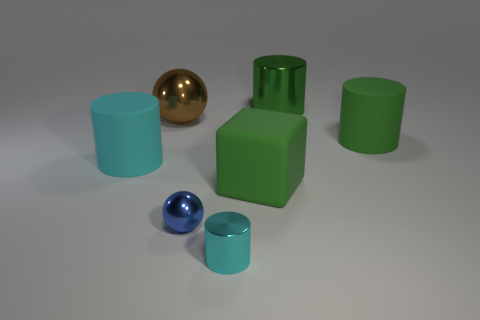Do the large green thing behind the large brown metallic thing and the big green block have the same material?
Your answer should be very brief. No. The large sphere that is made of the same material as the tiny cyan thing is what color?
Your response must be concise. Brown. Is the number of matte cubes that are behind the brown thing less than the number of rubber cylinders that are to the right of the green metallic thing?
Make the answer very short. Yes. There is a thing that is behind the brown sphere; is it the same color as the matte thing that is in front of the cyan matte cylinder?
Offer a terse response. Yes. Is there a big brown sphere that has the same material as the tiny cyan object?
Offer a terse response. Yes. What is the size of the cyan object right of the ball that is on the left side of the tiny blue sphere?
Make the answer very short. Small. Are there more small green metal spheres than small shiny cylinders?
Provide a short and direct response. No. There is a green rubber thing in front of the green rubber cylinder; is its size the same as the brown shiny ball?
Your response must be concise. Yes. What number of metallic spheres are the same color as the big rubber block?
Make the answer very short. 0. Is the blue metal object the same shape as the large brown object?
Give a very brief answer. Yes. 